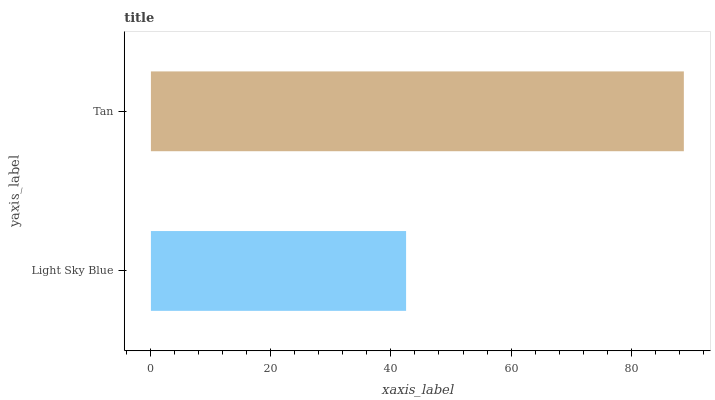Is Light Sky Blue the minimum?
Answer yes or no. Yes. Is Tan the maximum?
Answer yes or no. Yes. Is Tan the minimum?
Answer yes or no. No. Is Tan greater than Light Sky Blue?
Answer yes or no. Yes. Is Light Sky Blue less than Tan?
Answer yes or no. Yes. Is Light Sky Blue greater than Tan?
Answer yes or no. No. Is Tan less than Light Sky Blue?
Answer yes or no. No. Is Tan the high median?
Answer yes or no. Yes. Is Light Sky Blue the low median?
Answer yes or no. Yes. Is Light Sky Blue the high median?
Answer yes or no. No. Is Tan the low median?
Answer yes or no. No. 